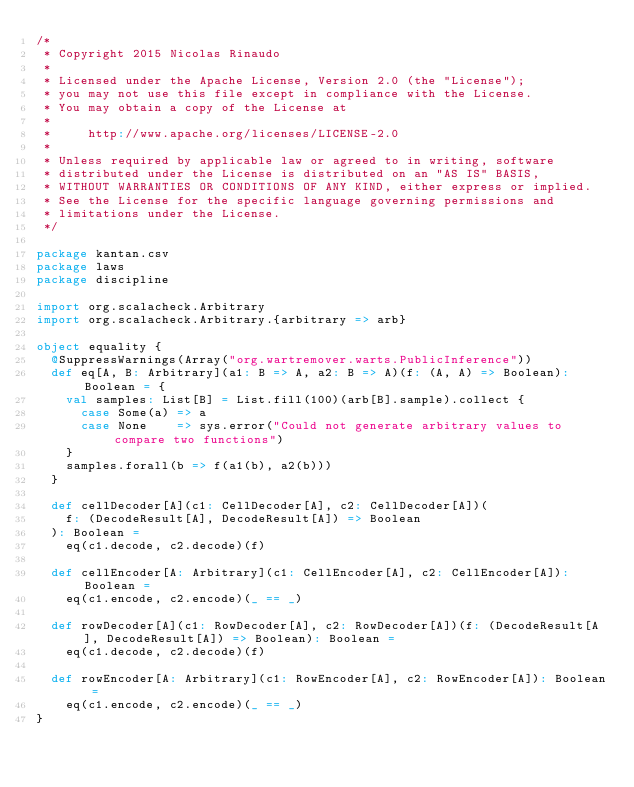<code> <loc_0><loc_0><loc_500><loc_500><_Scala_>/*
 * Copyright 2015 Nicolas Rinaudo
 *
 * Licensed under the Apache License, Version 2.0 (the "License");
 * you may not use this file except in compliance with the License.
 * You may obtain a copy of the License at
 *
 *     http://www.apache.org/licenses/LICENSE-2.0
 *
 * Unless required by applicable law or agreed to in writing, software
 * distributed under the License is distributed on an "AS IS" BASIS,
 * WITHOUT WARRANTIES OR CONDITIONS OF ANY KIND, either express or implied.
 * See the License for the specific language governing permissions and
 * limitations under the License.
 */

package kantan.csv
package laws
package discipline

import org.scalacheck.Arbitrary
import org.scalacheck.Arbitrary.{arbitrary => arb}

object equality {
  @SuppressWarnings(Array("org.wartremover.warts.PublicInference"))
  def eq[A, B: Arbitrary](a1: B => A, a2: B => A)(f: (A, A) => Boolean): Boolean = {
    val samples: List[B] = List.fill(100)(arb[B].sample).collect {
      case Some(a) => a
      case None    => sys.error("Could not generate arbitrary values to compare two functions")
    }
    samples.forall(b => f(a1(b), a2(b)))
  }

  def cellDecoder[A](c1: CellDecoder[A], c2: CellDecoder[A])(
    f: (DecodeResult[A], DecodeResult[A]) => Boolean
  ): Boolean =
    eq(c1.decode, c2.decode)(f)

  def cellEncoder[A: Arbitrary](c1: CellEncoder[A], c2: CellEncoder[A]): Boolean =
    eq(c1.encode, c2.encode)(_ == _)

  def rowDecoder[A](c1: RowDecoder[A], c2: RowDecoder[A])(f: (DecodeResult[A], DecodeResult[A]) => Boolean): Boolean =
    eq(c1.decode, c2.decode)(f)

  def rowEncoder[A: Arbitrary](c1: RowEncoder[A], c2: RowEncoder[A]): Boolean =
    eq(c1.encode, c2.encode)(_ == _)
}
</code> 